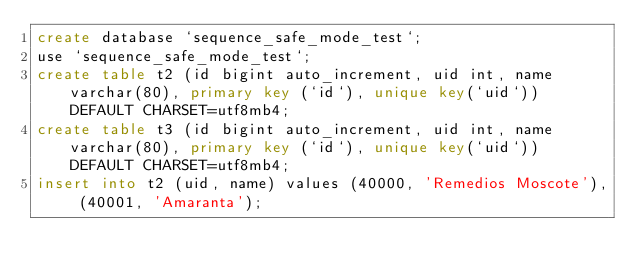<code> <loc_0><loc_0><loc_500><loc_500><_SQL_>create database `sequence_safe_mode_test`;
use `sequence_safe_mode_test`;
create table t2 (id bigint auto_increment, uid int, name varchar(80), primary key (`id`), unique key(`uid`)) DEFAULT CHARSET=utf8mb4;
create table t3 (id bigint auto_increment, uid int, name varchar(80), primary key (`id`), unique key(`uid`)) DEFAULT CHARSET=utf8mb4;
insert into t2 (uid, name) values (40000, 'Remedios Moscote'), (40001, 'Amaranta');</code> 